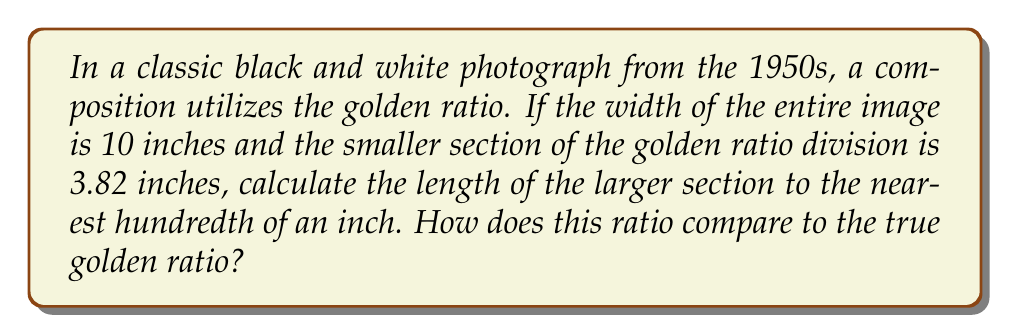Can you solve this math problem? Let's approach this step-by-step:

1) The golden ratio, denoted by φ (phi), is approximately 1.618034...

2) In a golden ratio composition, the ratio of the whole to the larger part is equal to the ratio of the larger part to the smaller part.

3) Let x be the length of the larger section. We know:
   - Total width = 10 inches
   - Smaller section = 3.82 inches
   - Larger section = x inches

4) We can set up the equation:
   $$ \frac{10}{x} = \frac{x}{3.82} $$

5) Cross multiply:
   $$ 10 * 3.82 = x^2 $$

6) Solve for x:
   $$ x^2 = 38.2 $$
   $$ x = \sqrt{38.2} $$
   $$ x ≈ 6.18 \text{ inches} $$

7) To compare with the true golden ratio:
   $$ \frac{\text{Whole}}{\text{Larger part}} = \frac{10}{6.18} ≈ 1.6181 $$

8) The true golden ratio is approximately 1.618034...

[asy]
size(200);
draw((0,0)--(10,0));
draw((6.18,0)--(6.18,0.5));
label("10", (5,-0.5));
label("6.18", (3.09,0.25));
label("3.82", (8.09,0.25));
[/asy]
Answer: 6.18 inches; nearly identical to true golden ratio 